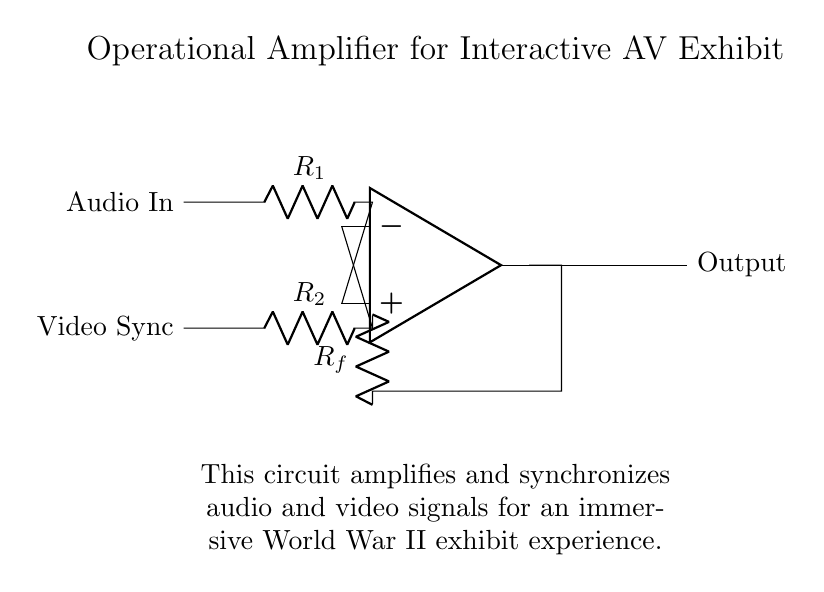What are the two input signals for this operational amplifier? The circuit has two input signals labeled as "Audio In" and "Video Sync" located on the left side of the diagram where the inputs connect to the operational amplifier.
Answer: Audio In, Video Sync What component is used for feedback in the circuit? The diagram shows a resistor labeled as R_f connected from the output of the operational amplifier back to its inverting input, indicating that it is the feedback component.
Answer: R_f What is the purpose of the operational amplifier in this circuit? The operational amplifier is designed to amplify and synchronize the input audio and video signals, enabling a more immersive experience, as described in the circuit's summary.
Answer: Amplification and synchronization Which resistor is connected to the non-inverting input? The resistor labeled R_1 is connected to the non-inverting input of the operational amplifier, indicated by its position in the circuit diagram.
Answer: R_1 How many resistors are present in this circuit? There are three resistors visible in the circuit: R_1, R_2, and R_f, each serving different roles in the amplification process.
Answer: Three What does the output of the operational amplifier connect to? The output of the operational amplifier connects to a node labeled as "Output" on the right side of the diagram, confirming where the amplified signal is sent.
Answer: Output What is the function of the resistor R_2 in the circuit? Resistor R_2 is connected to the inverting input of the operational amplifier and plays a critical role in setting the gain of the amplifier along with R_f. Its presence helps to control the feedback and stabilization of the circuit's function.
Answer: Gain control 